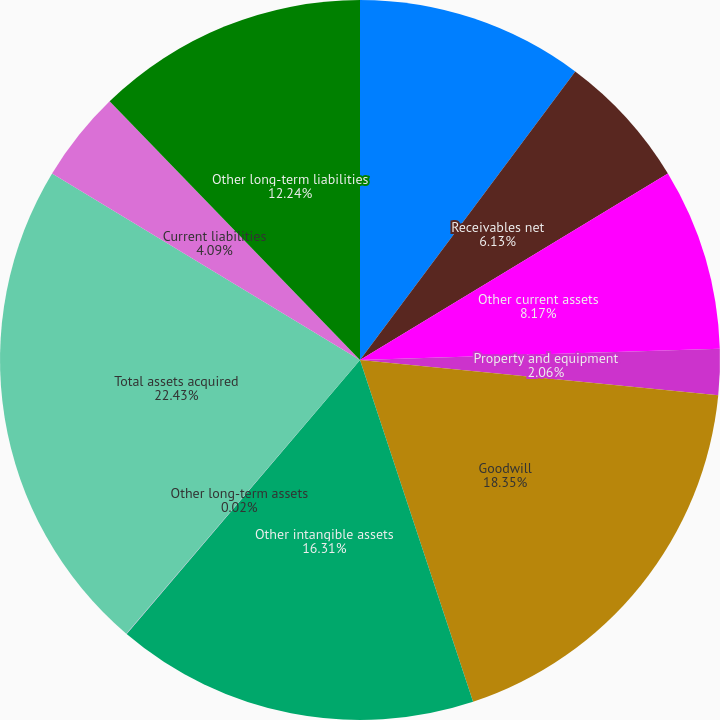<chart> <loc_0><loc_0><loc_500><loc_500><pie_chart><fcel>Cash and cash equivalents<fcel>Receivables net<fcel>Other current assets<fcel>Property and equipment<fcel>Goodwill<fcel>Other intangible assets<fcel>Other long-term assets<fcel>Total assets acquired<fcel>Current liabilities<fcel>Other long-term liabilities<nl><fcel>10.2%<fcel>6.13%<fcel>8.17%<fcel>2.06%<fcel>18.35%<fcel>16.31%<fcel>0.02%<fcel>22.42%<fcel>4.09%<fcel>12.24%<nl></chart> 